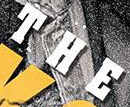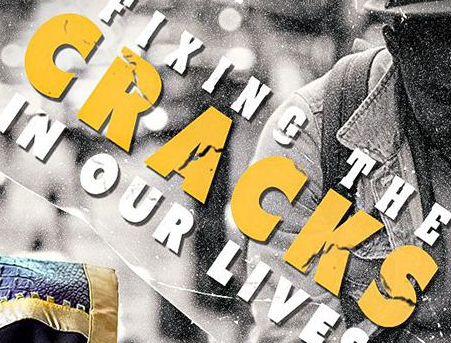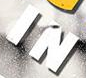Transcribe the words shown in these images in order, separated by a semicolon. THE; CRACKS; IN 